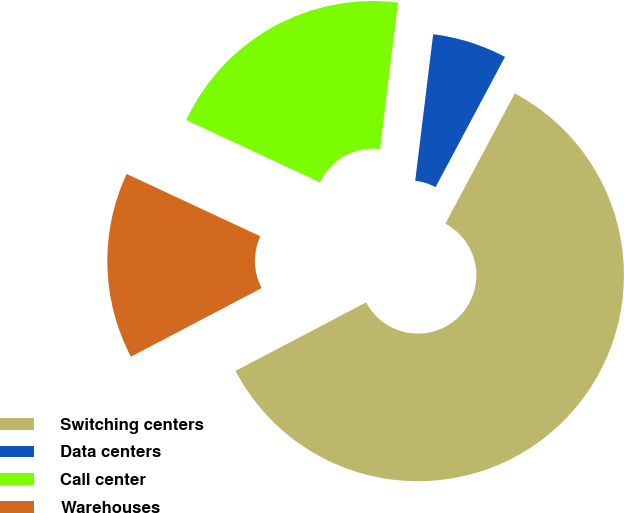Convert chart. <chart><loc_0><loc_0><loc_500><loc_500><pie_chart><fcel>Switching centers<fcel>Data centers<fcel>Call center<fcel>Warehouses<nl><fcel>59.51%<fcel>5.85%<fcel>20.0%<fcel>14.63%<nl></chart> 